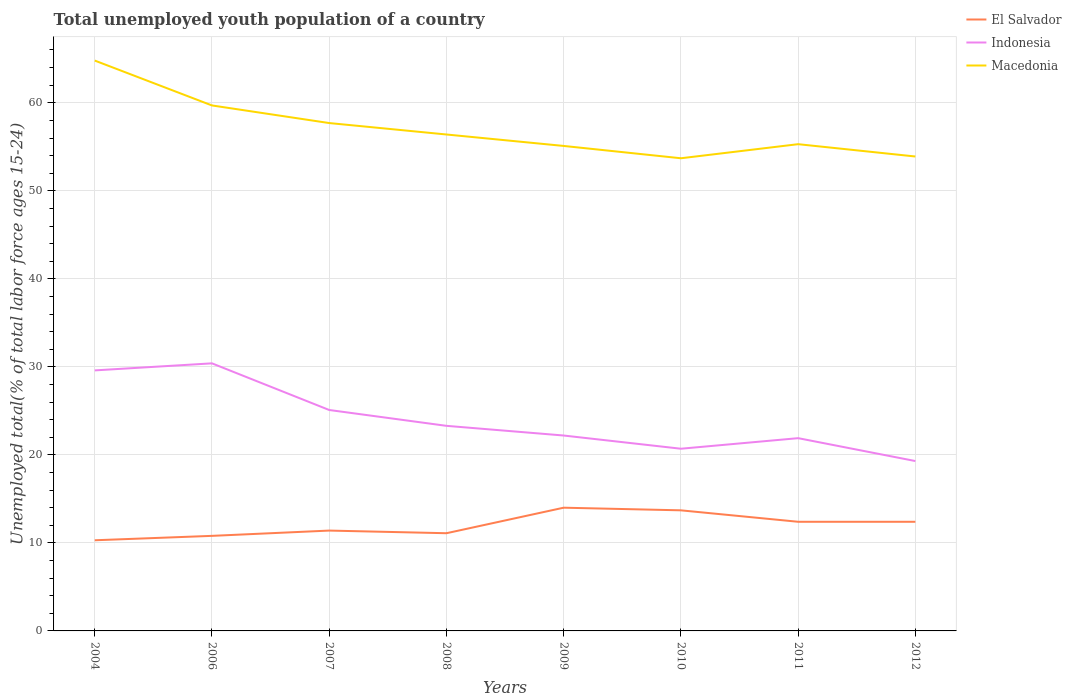How many different coloured lines are there?
Offer a terse response. 3. Is the number of lines equal to the number of legend labels?
Offer a very short reply. Yes. Across all years, what is the maximum percentage of total unemployed youth population of a country in Indonesia?
Offer a very short reply. 19.3. What is the total percentage of total unemployed youth population of a country in Indonesia in the graph?
Keep it short and to the point. 7.7. What is the difference between the highest and the second highest percentage of total unemployed youth population of a country in El Salvador?
Make the answer very short. 3.7. What is the difference between the highest and the lowest percentage of total unemployed youth population of a country in Indonesia?
Your response must be concise. 3. Is the percentage of total unemployed youth population of a country in El Salvador strictly greater than the percentage of total unemployed youth population of a country in Macedonia over the years?
Keep it short and to the point. Yes. How many lines are there?
Ensure brevity in your answer.  3. How many years are there in the graph?
Provide a short and direct response. 8. Are the values on the major ticks of Y-axis written in scientific E-notation?
Make the answer very short. No. Where does the legend appear in the graph?
Your answer should be very brief. Top right. What is the title of the graph?
Make the answer very short. Total unemployed youth population of a country. Does "Curacao" appear as one of the legend labels in the graph?
Ensure brevity in your answer.  No. What is the label or title of the Y-axis?
Provide a succinct answer. Unemployed total(% of total labor force ages 15-24). What is the Unemployed total(% of total labor force ages 15-24) of El Salvador in 2004?
Your answer should be compact. 10.3. What is the Unemployed total(% of total labor force ages 15-24) in Indonesia in 2004?
Provide a short and direct response. 29.6. What is the Unemployed total(% of total labor force ages 15-24) in Macedonia in 2004?
Offer a terse response. 64.8. What is the Unemployed total(% of total labor force ages 15-24) of El Salvador in 2006?
Keep it short and to the point. 10.8. What is the Unemployed total(% of total labor force ages 15-24) in Indonesia in 2006?
Make the answer very short. 30.4. What is the Unemployed total(% of total labor force ages 15-24) of Macedonia in 2006?
Your response must be concise. 59.7. What is the Unemployed total(% of total labor force ages 15-24) in El Salvador in 2007?
Make the answer very short. 11.4. What is the Unemployed total(% of total labor force ages 15-24) of Indonesia in 2007?
Keep it short and to the point. 25.1. What is the Unemployed total(% of total labor force ages 15-24) of Macedonia in 2007?
Ensure brevity in your answer.  57.7. What is the Unemployed total(% of total labor force ages 15-24) of El Salvador in 2008?
Ensure brevity in your answer.  11.1. What is the Unemployed total(% of total labor force ages 15-24) in Indonesia in 2008?
Your answer should be compact. 23.3. What is the Unemployed total(% of total labor force ages 15-24) in Macedonia in 2008?
Give a very brief answer. 56.4. What is the Unemployed total(% of total labor force ages 15-24) in El Salvador in 2009?
Provide a short and direct response. 14. What is the Unemployed total(% of total labor force ages 15-24) in Indonesia in 2009?
Your answer should be compact. 22.2. What is the Unemployed total(% of total labor force ages 15-24) in Macedonia in 2009?
Your answer should be compact. 55.1. What is the Unemployed total(% of total labor force ages 15-24) of El Salvador in 2010?
Your answer should be compact. 13.7. What is the Unemployed total(% of total labor force ages 15-24) in Indonesia in 2010?
Provide a short and direct response. 20.7. What is the Unemployed total(% of total labor force ages 15-24) of Macedonia in 2010?
Provide a short and direct response. 53.7. What is the Unemployed total(% of total labor force ages 15-24) of El Salvador in 2011?
Ensure brevity in your answer.  12.4. What is the Unemployed total(% of total labor force ages 15-24) in Indonesia in 2011?
Keep it short and to the point. 21.9. What is the Unemployed total(% of total labor force ages 15-24) of Macedonia in 2011?
Your response must be concise. 55.3. What is the Unemployed total(% of total labor force ages 15-24) of El Salvador in 2012?
Provide a short and direct response. 12.4. What is the Unemployed total(% of total labor force ages 15-24) of Indonesia in 2012?
Ensure brevity in your answer.  19.3. What is the Unemployed total(% of total labor force ages 15-24) of Macedonia in 2012?
Offer a terse response. 53.9. Across all years, what is the maximum Unemployed total(% of total labor force ages 15-24) of Indonesia?
Give a very brief answer. 30.4. Across all years, what is the maximum Unemployed total(% of total labor force ages 15-24) of Macedonia?
Ensure brevity in your answer.  64.8. Across all years, what is the minimum Unemployed total(% of total labor force ages 15-24) of El Salvador?
Your answer should be compact. 10.3. Across all years, what is the minimum Unemployed total(% of total labor force ages 15-24) in Indonesia?
Make the answer very short. 19.3. Across all years, what is the minimum Unemployed total(% of total labor force ages 15-24) in Macedonia?
Provide a succinct answer. 53.7. What is the total Unemployed total(% of total labor force ages 15-24) in El Salvador in the graph?
Your answer should be very brief. 96.1. What is the total Unemployed total(% of total labor force ages 15-24) in Indonesia in the graph?
Offer a very short reply. 192.5. What is the total Unemployed total(% of total labor force ages 15-24) of Macedonia in the graph?
Your answer should be very brief. 456.6. What is the difference between the Unemployed total(% of total labor force ages 15-24) in El Salvador in 2004 and that in 2006?
Provide a short and direct response. -0.5. What is the difference between the Unemployed total(% of total labor force ages 15-24) in El Salvador in 2004 and that in 2008?
Ensure brevity in your answer.  -0.8. What is the difference between the Unemployed total(% of total labor force ages 15-24) in Indonesia in 2004 and that in 2008?
Offer a very short reply. 6.3. What is the difference between the Unemployed total(% of total labor force ages 15-24) of El Salvador in 2004 and that in 2010?
Offer a very short reply. -3.4. What is the difference between the Unemployed total(% of total labor force ages 15-24) of Indonesia in 2004 and that in 2010?
Give a very brief answer. 8.9. What is the difference between the Unemployed total(% of total labor force ages 15-24) of El Salvador in 2004 and that in 2011?
Provide a succinct answer. -2.1. What is the difference between the Unemployed total(% of total labor force ages 15-24) in El Salvador in 2004 and that in 2012?
Keep it short and to the point. -2.1. What is the difference between the Unemployed total(% of total labor force ages 15-24) in Indonesia in 2006 and that in 2007?
Provide a succinct answer. 5.3. What is the difference between the Unemployed total(% of total labor force ages 15-24) in Macedonia in 2006 and that in 2007?
Make the answer very short. 2. What is the difference between the Unemployed total(% of total labor force ages 15-24) of Indonesia in 2006 and that in 2008?
Your response must be concise. 7.1. What is the difference between the Unemployed total(% of total labor force ages 15-24) in Macedonia in 2006 and that in 2008?
Make the answer very short. 3.3. What is the difference between the Unemployed total(% of total labor force ages 15-24) of El Salvador in 2006 and that in 2009?
Provide a short and direct response. -3.2. What is the difference between the Unemployed total(% of total labor force ages 15-24) in Indonesia in 2006 and that in 2009?
Provide a succinct answer. 8.2. What is the difference between the Unemployed total(% of total labor force ages 15-24) of El Salvador in 2006 and that in 2010?
Give a very brief answer. -2.9. What is the difference between the Unemployed total(% of total labor force ages 15-24) of Indonesia in 2006 and that in 2010?
Offer a very short reply. 9.7. What is the difference between the Unemployed total(% of total labor force ages 15-24) in Macedonia in 2006 and that in 2011?
Give a very brief answer. 4.4. What is the difference between the Unemployed total(% of total labor force ages 15-24) in Indonesia in 2006 and that in 2012?
Ensure brevity in your answer.  11.1. What is the difference between the Unemployed total(% of total labor force ages 15-24) in Macedonia in 2006 and that in 2012?
Ensure brevity in your answer.  5.8. What is the difference between the Unemployed total(% of total labor force ages 15-24) of Indonesia in 2007 and that in 2008?
Keep it short and to the point. 1.8. What is the difference between the Unemployed total(% of total labor force ages 15-24) in Macedonia in 2007 and that in 2008?
Provide a short and direct response. 1.3. What is the difference between the Unemployed total(% of total labor force ages 15-24) in Indonesia in 2007 and that in 2009?
Offer a terse response. 2.9. What is the difference between the Unemployed total(% of total labor force ages 15-24) in Indonesia in 2007 and that in 2010?
Your answer should be very brief. 4.4. What is the difference between the Unemployed total(% of total labor force ages 15-24) in El Salvador in 2007 and that in 2012?
Ensure brevity in your answer.  -1. What is the difference between the Unemployed total(% of total labor force ages 15-24) in Macedonia in 2007 and that in 2012?
Your answer should be compact. 3.8. What is the difference between the Unemployed total(% of total labor force ages 15-24) of Indonesia in 2008 and that in 2009?
Make the answer very short. 1.1. What is the difference between the Unemployed total(% of total labor force ages 15-24) of El Salvador in 2008 and that in 2010?
Give a very brief answer. -2.6. What is the difference between the Unemployed total(% of total labor force ages 15-24) in Macedonia in 2008 and that in 2010?
Give a very brief answer. 2.7. What is the difference between the Unemployed total(% of total labor force ages 15-24) in Indonesia in 2008 and that in 2011?
Your response must be concise. 1.4. What is the difference between the Unemployed total(% of total labor force ages 15-24) of Macedonia in 2008 and that in 2011?
Ensure brevity in your answer.  1.1. What is the difference between the Unemployed total(% of total labor force ages 15-24) of Indonesia in 2008 and that in 2012?
Offer a very short reply. 4. What is the difference between the Unemployed total(% of total labor force ages 15-24) of El Salvador in 2009 and that in 2010?
Provide a short and direct response. 0.3. What is the difference between the Unemployed total(% of total labor force ages 15-24) in Macedonia in 2009 and that in 2010?
Offer a terse response. 1.4. What is the difference between the Unemployed total(% of total labor force ages 15-24) in El Salvador in 2009 and that in 2011?
Offer a very short reply. 1.6. What is the difference between the Unemployed total(% of total labor force ages 15-24) of Macedonia in 2009 and that in 2011?
Offer a terse response. -0.2. What is the difference between the Unemployed total(% of total labor force ages 15-24) of El Salvador in 2009 and that in 2012?
Your answer should be compact. 1.6. What is the difference between the Unemployed total(% of total labor force ages 15-24) of Indonesia in 2009 and that in 2012?
Your response must be concise. 2.9. What is the difference between the Unemployed total(% of total labor force ages 15-24) in Macedonia in 2009 and that in 2012?
Provide a short and direct response. 1.2. What is the difference between the Unemployed total(% of total labor force ages 15-24) of El Salvador in 2010 and that in 2011?
Offer a very short reply. 1.3. What is the difference between the Unemployed total(% of total labor force ages 15-24) of Indonesia in 2010 and that in 2011?
Your answer should be compact. -1.2. What is the difference between the Unemployed total(% of total labor force ages 15-24) in Indonesia in 2010 and that in 2012?
Ensure brevity in your answer.  1.4. What is the difference between the Unemployed total(% of total labor force ages 15-24) in El Salvador in 2011 and that in 2012?
Your answer should be compact. 0. What is the difference between the Unemployed total(% of total labor force ages 15-24) of El Salvador in 2004 and the Unemployed total(% of total labor force ages 15-24) of Indonesia in 2006?
Provide a succinct answer. -20.1. What is the difference between the Unemployed total(% of total labor force ages 15-24) in El Salvador in 2004 and the Unemployed total(% of total labor force ages 15-24) in Macedonia in 2006?
Provide a succinct answer. -49.4. What is the difference between the Unemployed total(% of total labor force ages 15-24) in Indonesia in 2004 and the Unemployed total(% of total labor force ages 15-24) in Macedonia in 2006?
Give a very brief answer. -30.1. What is the difference between the Unemployed total(% of total labor force ages 15-24) of El Salvador in 2004 and the Unemployed total(% of total labor force ages 15-24) of Indonesia in 2007?
Provide a short and direct response. -14.8. What is the difference between the Unemployed total(% of total labor force ages 15-24) in El Salvador in 2004 and the Unemployed total(% of total labor force ages 15-24) in Macedonia in 2007?
Offer a very short reply. -47.4. What is the difference between the Unemployed total(% of total labor force ages 15-24) in Indonesia in 2004 and the Unemployed total(% of total labor force ages 15-24) in Macedonia in 2007?
Offer a terse response. -28.1. What is the difference between the Unemployed total(% of total labor force ages 15-24) of El Salvador in 2004 and the Unemployed total(% of total labor force ages 15-24) of Indonesia in 2008?
Offer a terse response. -13. What is the difference between the Unemployed total(% of total labor force ages 15-24) of El Salvador in 2004 and the Unemployed total(% of total labor force ages 15-24) of Macedonia in 2008?
Your answer should be very brief. -46.1. What is the difference between the Unemployed total(% of total labor force ages 15-24) in Indonesia in 2004 and the Unemployed total(% of total labor force ages 15-24) in Macedonia in 2008?
Provide a short and direct response. -26.8. What is the difference between the Unemployed total(% of total labor force ages 15-24) in El Salvador in 2004 and the Unemployed total(% of total labor force ages 15-24) in Indonesia in 2009?
Provide a succinct answer. -11.9. What is the difference between the Unemployed total(% of total labor force ages 15-24) of El Salvador in 2004 and the Unemployed total(% of total labor force ages 15-24) of Macedonia in 2009?
Make the answer very short. -44.8. What is the difference between the Unemployed total(% of total labor force ages 15-24) of Indonesia in 2004 and the Unemployed total(% of total labor force ages 15-24) of Macedonia in 2009?
Ensure brevity in your answer.  -25.5. What is the difference between the Unemployed total(% of total labor force ages 15-24) of El Salvador in 2004 and the Unemployed total(% of total labor force ages 15-24) of Indonesia in 2010?
Give a very brief answer. -10.4. What is the difference between the Unemployed total(% of total labor force ages 15-24) of El Salvador in 2004 and the Unemployed total(% of total labor force ages 15-24) of Macedonia in 2010?
Your answer should be very brief. -43.4. What is the difference between the Unemployed total(% of total labor force ages 15-24) in Indonesia in 2004 and the Unemployed total(% of total labor force ages 15-24) in Macedonia in 2010?
Your response must be concise. -24.1. What is the difference between the Unemployed total(% of total labor force ages 15-24) of El Salvador in 2004 and the Unemployed total(% of total labor force ages 15-24) of Macedonia in 2011?
Offer a terse response. -45. What is the difference between the Unemployed total(% of total labor force ages 15-24) of Indonesia in 2004 and the Unemployed total(% of total labor force ages 15-24) of Macedonia in 2011?
Ensure brevity in your answer.  -25.7. What is the difference between the Unemployed total(% of total labor force ages 15-24) of El Salvador in 2004 and the Unemployed total(% of total labor force ages 15-24) of Indonesia in 2012?
Make the answer very short. -9. What is the difference between the Unemployed total(% of total labor force ages 15-24) of El Salvador in 2004 and the Unemployed total(% of total labor force ages 15-24) of Macedonia in 2012?
Give a very brief answer. -43.6. What is the difference between the Unemployed total(% of total labor force ages 15-24) in Indonesia in 2004 and the Unemployed total(% of total labor force ages 15-24) in Macedonia in 2012?
Make the answer very short. -24.3. What is the difference between the Unemployed total(% of total labor force ages 15-24) in El Salvador in 2006 and the Unemployed total(% of total labor force ages 15-24) in Indonesia in 2007?
Your answer should be very brief. -14.3. What is the difference between the Unemployed total(% of total labor force ages 15-24) of El Salvador in 2006 and the Unemployed total(% of total labor force ages 15-24) of Macedonia in 2007?
Offer a very short reply. -46.9. What is the difference between the Unemployed total(% of total labor force ages 15-24) of Indonesia in 2006 and the Unemployed total(% of total labor force ages 15-24) of Macedonia in 2007?
Keep it short and to the point. -27.3. What is the difference between the Unemployed total(% of total labor force ages 15-24) of El Salvador in 2006 and the Unemployed total(% of total labor force ages 15-24) of Macedonia in 2008?
Keep it short and to the point. -45.6. What is the difference between the Unemployed total(% of total labor force ages 15-24) of El Salvador in 2006 and the Unemployed total(% of total labor force ages 15-24) of Macedonia in 2009?
Your answer should be compact. -44.3. What is the difference between the Unemployed total(% of total labor force ages 15-24) in Indonesia in 2006 and the Unemployed total(% of total labor force ages 15-24) in Macedonia in 2009?
Give a very brief answer. -24.7. What is the difference between the Unemployed total(% of total labor force ages 15-24) of El Salvador in 2006 and the Unemployed total(% of total labor force ages 15-24) of Indonesia in 2010?
Make the answer very short. -9.9. What is the difference between the Unemployed total(% of total labor force ages 15-24) in El Salvador in 2006 and the Unemployed total(% of total labor force ages 15-24) in Macedonia in 2010?
Give a very brief answer. -42.9. What is the difference between the Unemployed total(% of total labor force ages 15-24) of Indonesia in 2006 and the Unemployed total(% of total labor force ages 15-24) of Macedonia in 2010?
Provide a succinct answer. -23.3. What is the difference between the Unemployed total(% of total labor force ages 15-24) of El Salvador in 2006 and the Unemployed total(% of total labor force ages 15-24) of Macedonia in 2011?
Provide a succinct answer. -44.5. What is the difference between the Unemployed total(% of total labor force ages 15-24) of Indonesia in 2006 and the Unemployed total(% of total labor force ages 15-24) of Macedonia in 2011?
Provide a succinct answer. -24.9. What is the difference between the Unemployed total(% of total labor force ages 15-24) of El Salvador in 2006 and the Unemployed total(% of total labor force ages 15-24) of Macedonia in 2012?
Offer a terse response. -43.1. What is the difference between the Unemployed total(% of total labor force ages 15-24) of Indonesia in 2006 and the Unemployed total(% of total labor force ages 15-24) of Macedonia in 2012?
Provide a short and direct response. -23.5. What is the difference between the Unemployed total(% of total labor force ages 15-24) of El Salvador in 2007 and the Unemployed total(% of total labor force ages 15-24) of Indonesia in 2008?
Your answer should be compact. -11.9. What is the difference between the Unemployed total(% of total labor force ages 15-24) in El Salvador in 2007 and the Unemployed total(% of total labor force ages 15-24) in Macedonia in 2008?
Give a very brief answer. -45. What is the difference between the Unemployed total(% of total labor force ages 15-24) of Indonesia in 2007 and the Unemployed total(% of total labor force ages 15-24) of Macedonia in 2008?
Provide a succinct answer. -31.3. What is the difference between the Unemployed total(% of total labor force ages 15-24) in El Salvador in 2007 and the Unemployed total(% of total labor force ages 15-24) in Macedonia in 2009?
Your answer should be very brief. -43.7. What is the difference between the Unemployed total(% of total labor force ages 15-24) in El Salvador in 2007 and the Unemployed total(% of total labor force ages 15-24) in Indonesia in 2010?
Your response must be concise. -9.3. What is the difference between the Unemployed total(% of total labor force ages 15-24) of El Salvador in 2007 and the Unemployed total(% of total labor force ages 15-24) of Macedonia in 2010?
Provide a short and direct response. -42.3. What is the difference between the Unemployed total(% of total labor force ages 15-24) of Indonesia in 2007 and the Unemployed total(% of total labor force ages 15-24) of Macedonia in 2010?
Keep it short and to the point. -28.6. What is the difference between the Unemployed total(% of total labor force ages 15-24) of El Salvador in 2007 and the Unemployed total(% of total labor force ages 15-24) of Macedonia in 2011?
Your answer should be very brief. -43.9. What is the difference between the Unemployed total(% of total labor force ages 15-24) of Indonesia in 2007 and the Unemployed total(% of total labor force ages 15-24) of Macedonia in 2011?
Provide a short and direct response. -30.2. What is the difference between the Unemployed total(% of total labor force ages 15-24) in El Salvador in 2007 and the Unemployed total(% of total labor force ages 15-24) in Indonesia in 2012?
Ensure brevity in your answer.  -7.9. What is the difference between the Unemployed total(% of total labor force ages 15-24) in El Salvador in 2007 and the Unemployed total(% of total labor force ages 15-24) in Macedonia in 2012?
Keep it short and to the point. -42.5. What is the difference between the Unemployed total(% of total labor force ages 15-24) in Indonesia in 2007 and the Unemployed total(% of total labor force ages 15-24) in Macedonia in 2012?
Provide a succinct answer. -28.8. What is the difference between the Unemployed total(% of total labor force ages 15-24) in El Salvador in 2008 and the Unemployed total(% of total labor force ages 15-24) in Macedonia in 2009?
Provide a short and direct response. -44. What is the difference between the Unemployed total(% of total labor force ages 15-24) of Indonesia in 2008 and the Unemployed total(% of total labor force ages 15-24) of Macedonia in 2009?
Keep it short and to the point. -31.8. What is the difference between the Unemployed total(% of total labor force ages 15-24) of El Salvador in 2008 and the Unemployed total(% of total labor force ages 15-24) of Macedonia in 2010?
Offer a very short reply. -42.6. What is the difference between the Unemployed total(% of total labor force ages 15-24) of Indonesia in 2008 and the Unemployed total(% of total labor force ages 15-24) of Macedonia in 2010?
Keep it short and to the point. -30.4. What is the difference between the Unemployed total(% of total labor force ages 15-24) in El Salvador in 2008 and the Unemployed total(% of total labor force ages 15-24) in Indonesia in 2011?
Provide a succinct answer. -10.8. What is the difference between the Unemployed total(% of total labor force ages 15-24) in El Salvador in 2008 and the Unemployed total(% of total labor force ages 15-24) in Macedonia in 2011?
Ensure brevity in your answer.  -44.2. What is the difference between the Unemployed total(% of total labor force ages 15-24) of Indonesia in 2008 and the Unemployed total(% of total labor force ages 15-24) of Macedonia in 2011?
Provide a succinct answer. -32. What is the difference between the Unemployed total(% of total labor force ages 15-24) in El Salvador in 2008 and the Unemployed total(% of total labor force ages 15-24) in Indonesia in 2012?
Your answer should be compact. -8.2. What is the difference between the Unemployed total(% of total labor force ages 15-24) in El Salvador in 2008 and the Unemployed total(% of total labor force ages 15-24) in Macedonia in 2012?
Give a very brief answer. -42.8. What is the difference between the Unemployed total(% of total labor force ages 15-24) of Indonesia in 2008 and the Unemployed total(% of total labor force ages 15-24) of Macedonia in 2012?
Offer a very short reply. -30.6. What is the difference between the Unemployed total(% of total labor force ages 15-24) in El Salvador in 2009 and the Unemployed total(% of total labor force ages 15-24) in Macedonia in 2010?
Give a very brief answer. -39.7. What is the difference between the Unemployed total(% of total labor force ages 15-24) in Indonesia in 2009 and the Unemployed total(% of total labor force ages 15-24) in Macedonia in 2010?
Give a very brief answer. -31.5. What is the difference between the Unemployed total(% of total labor force ages 15-24) in El Salvador in 2009 and the Unemployed total(% of total labor force ages 15-24) in Indonesia in 2011?
Keep it short and to the point. -7.9. What is the difference between the Unemployed total(% of total labor force ages 15-24) of El Salvador in 2009 and the Unemployed total(% of total labor force ages 15-24) of Macedonia in 2011?
Keep it short and to the point. -41.3. What is the difference between the Unemployed total(% of total labor force ages 15-24) in Indonesia in 2009 and the Unemployed total(% of total labor force ages 15-24) in Macedonia in 2011?
Provide a succinct answer. -33.1. What is the difference between the Unemployed total(% of total labor force ages 15-24) in El Salvador in 2009 and the Unemployed total(% of total labor force ages 15-24) in Indonesia in 2012?
Provide a succinct answer. -5.3. What is the difference between the Unemployed total(% of total labor force ages 15-24) of El Salvador in 2009 and the Unemployed total(% of total labor force ages 15-24) of Macedonia in 2012?
Your response must be concise. -39.9. What is the difference between the Unemployed total(% of total labor force ages 15-24) in Indonesia in 2009 and the Unemployed total(% of total labor force ages 15-24) in Macedonia in 2012?
Ensure brevity in your answer.  -31.7. What is the difference between the Unemployed total(% of total labor force ages 15-24) in El Salvador in 2010 and the Unemployed total(% of total labor force ages 15-24) in Indonesia in 2011?
Give a very brief answer. -8.2. What is the difference between the Unemployed total(% of total labor force ages 15-24) in El Salvador in 2010 and the Unemployed total(% of total labor force ages 15-24) in Macedonia in 2011?
Make the answer very short. -41.6. What is the difference between the Unemployed total(% of total labor force ages 15-24) in Indonesia in 2010 and the Unemployed total(% of total labor force ages 15-24) in Macedonia in 2011?
Your answer should be compact. -34.6. What is the difference between the Unemployed total(% of total labor force ages 15-24) in El Salvador in 2010 and the Unemployed total(% of total labor force ages 15-24) in Macedonia in 2012?
Offer a very short reply. -40.2. What is the difference between the Unemployed total(% of total labor force ages 15-24) of Indonesia in 2010 and the Unemployed total(% of total labor force ages 15-24) of Macedonia in 2012?
Provide a short and direct response. -33.2. What is the difference between the Unemployed total(% of total labor force ages 15-24) in El Salvador in 2011 and the Unemployed total(% of total labor force ages 15-24) in Macedonia in 2012?
Provide a short and direct response. -41.5. What is the difference between the Unemployed total(% of total labor force ages 15-24) in Indonesia in 2011 and the Unemployed total(% of total labor force ages 15-24) in Macedonia in 2012?
Offer a very short reply. -32. What is the average Unemployed total(% of total labor force ages 15-24) of El Salvador per year?
Your answer should be compact. 12.01. What is the average Unemployed total(% of total labor force ages 15-24) of Indonesia per year?
Offer a very short reply. 24.06. What is the average Unemployed total(% of total labor force ages 15-24) of Macedonia per year?
Offer a very short reply. 57.08. In the year 2004, what is the difference between the Unemployed total(% of total labor force ages 15-24) of El Salvador and Unemployed total(% of total labor force ages 15-24) of Indonesia?
Keep it short and to the point. -19.3. In the year 2004, what is the difference between the Unemployed total(% of total labor force ages 15-24) in El Salvador and Unemployed total(% of total labor force ages 15-24) in Macedonia?
Your answer should be compact. -54.5. In the year 2004, what is the difference between the Unemployed total(% of total labor force ages 15-24) of Indonesia and Unemployed total(% of total labor force ages 15-24) of Macedonia?
Provide a succinct answer. -35.2. In the year 2006, what is the difference between the Unemployed total(% of total labor force ages 15-24) in El Salvador and Unemployed total(% of total labor force ages 15-24) in Indonesia?
Offer a terse response. -19.6. In the year 2006, what is the difference between the Unemployed total(% of total labor force ages 15-24) in El Salvador and Unemployed total(% of total labor force ages 15-24) in Macedonia?
Your answer should be compact. -48.9. In the year 2006, what is the difference between the Unemployed total(% of total labor force ages 15-24) in Indonesia and Unemployed total(% of total labor force ages 15-24) in Macedonia?
Ensure brevity in your answer.  -29.3. In the year 2007, what is the difference between the Unemployed total(% of total labor force ages 15-24) in El Salvador and Unemployed total(% of total labor force ages 15-24) in Indonesia?
Your answer should be compact. -13.7. In the year 2007, what is the difference between the Unemployed total(% of total labor force ages 15-24) of El Salvador and Unemployed total(% of total labor force ages 15-24) of Macedonia?
Keep it short and to the point. -46.3. In the year 2007, what is the difference between the Unemployed total(% of total labor force ages 15-24) of Indonesia and Unemployed total(% of total labor force ages 15-24) of Macedonia?
Ensure brevity in your answer.  -32.6. In the year 2008, what is the difference between the Unemployed total(% of total labor force ages 15-24) of El Salvador and Unemployed total(% of total labor force ages 15-24) of Indonesia?
Give a very brief answer. -12.2. In the year 2008, what is the difference between the Unemployed total(% of total labor force ages 15-24) in El Salvador and Unemployed total(% of total labor force ages 15-24) in Macedonia?
Provide a succinct answer. -45.3. In the year 2008, what is the difference between the Unemployed total(% of total labor force ages 15-24) in Indonesia and Unemployed total(% of total labor force ages 15-24) in Macedonia?
Your response must be concise. -33.1. In the year 2009, what is the difference between the Unemployed total(% of total labor force ages 15-24) of El Salvador and Unemployed total(% of total labor force ages 15-24) of Indonesia?
Give a very brief answer. -8.2. In the year 2009, what is the difference between the Unemployed total(% of total labor force ages 15-24) of El Salvador and Unemployed total(% of total labor force ages 15-24) of Macedonia?
Give a very brief answer. -41.1. In the year 2009, what is the difference between the Unemployed total(% of total labor force ages 15-24) in Indonesia and Unemployed total(% of total labor force ages 15-24) in Macedonia?
Give a very brief answer. -32.9. In the year 2010, what is the difference between the Unemployed total(% of total labor force ages 15-24) in El Salvador and Unemployed total(% of total labor force ages 15-24) in Indonesia?
Make the answer very short. -7. In the year 2010, what is the difference between the Unemployed total(% of total labor force ages 15-24) of El Salvador and Unemployed total(% of total labor force ages 15-24) of Macedonia?
Make the answer very short. -40. In the year 2010, what is the difference between the Unemployed total(% of total labor force ages 15-24) of Indonesia and Unemployed total(% of total labor force ages 15-24) of Macedonia?
Keep it short and to the point. -33. In the year 2011, what is the difference between the Unemployed total(% of total labor force ages 15-24) of El Salvador and Unemployed total(% of total labor force ages 15-24) of Indonesia?
Keep it short and to the point. -9.5. In the year 2011, what is the difference between the Unemployed total(% of total labor force ages 15-24) in El Salvador and Unemployed total(% of total labor force ages 15-24) in Macedonia?
Give a very brief answer. -42.9. In the year 2011, what is the difference between the Unemployed total(% of total labor force ages 15-24) of Indonesia and Unemployed total(% of total labor force ages 15-24) of Macedonia?
Give a very brief answer. -33.4. In the year 2012, what is the difference between the Unemployed total(% of total labor force ages 15-24) in El Salvador and Unemployed total(% of total labor force ages 15-24) in Indonesia?
Your answer should be very brief. -6.9. In the year 2012, what is the difference between the Unemployed total(% of total labor force ages 15-24) in El Salvador and Unemployed total(% of total labor force ages 15-24) in Macedonia?
Give a very brief answer. -41.5. In the year 2012, what is the difference between the Unemployed total(% of total labor force ages 15-24) of Indonesia and Unemployed total(% of total labor force ages 15-24) of Macedonia?
Your response must be concise. -34.6. What is the ratio of the Unemployed total(% of total labor force ages 15-24) of El Salvador in 2004 to that in 2006?
Keep it short and to the point. 0.95. What is the ratio of the Unemployed total(% of total labor force ages 15-24) in Indonesia in 2004 to that in 2006?
Give a very brief answer. 0.97. What is the ratio of the Unemployed total(% of total labor force ages 15-24) of Macedonia in 2004 to that in 2006?
Your response must be concise. 1.09. What is the ratio of the Unemployed total(% of total labor force ages 15-24) in El Salvador in 2004 to that in 2007?
Offer a very short reply. 0.9. What is the ratio of the Unemployed total(% of total labor force ages 15-24) in Indonesia in 2004 to that in 2007?
Your answer should be compact. 1.18. What is the ratio of the Unemployed total(% of total labor force ages 15-24) of Macedonia in 2004 to that in 2007?
Ensure brevity in your answer.  1.12. What is the ratio of the Unemployed total(% of total labor force ages 15-24) of El Salvador in 2004 to that in 2008?
Your answer should be very brief. 0.93. What is the ratio of the Unemployed total(% of total labor force ages 15-24) in Indonesia in 2004 to that in 2008?
Make the answer very short. 1.27. What is the ratio of the Unemployed total(% of total labor force ages 15-24) in Macedonia in 2004 to that in 2008?
Offer a very short reply. 1.15. What is the ratio of the Unemployed total(% of total labor force ages 15-24) of El Salvador in 2004 to that in 2009?
Ensure brevity in your answer.  0.74. What is the ratio of the Unemployed total(% of total labor force ages 15-24) of Macedonia in 2004 to that in 2009?
Your answer should be compact. 1.18. What is the ratio of the Unemployed total(% of total labor force ages 15-24) of El Salvador in 2004 to that in 2010?
Make the answer very short. 0.75. What is the ratio of the Unemployed total(% of total labor force ages 15-24) in Indonesia in 2004 to that in 2010?
Provide a succinct answer. 1.43. What is the ratio of the Unemployed total(% of total labor force ages 15-24) in Macedonia in 2004 to that in 2010?
Your answer should be compact. 1.21. What is the ratio of the Unemployed total(% of total labor force ages 15-24) in El Salvador in 2004 to that in 2011?
Give a very brief answer. 0.83. What is the ratio of the Unemployed total(% of total labor force ages 15-24) of Indonesia in 2004 to that in 2011?
Provide a succinct answer. 1.35. What is the ratio of the Unemployed total(% of total labor force ages 15-24) of Macedonia in 2004 to that in 2011?
Your answer should be compact. 1.17. What is the ratio of the Unemployed total(% of total labor force ages 15-24) in El Salvador in 2004 to that in 2012?
Ensure brevity in your answer.  0.83. What is the ratio of the Unemployed total(% of total labor force ages 15-24) in Indonesia in 2004 to that in 2012?
Keep it short and to the point. 1.53. What is the ratio of the Unemployed total(% of total labor force ages 15-24) in Macedonia in 2004 to that in 2012?
Give a very brief answer. 1.2. What is the ratio of the Unemployed total(% of total labor force ages 15-24) of El Salvador in 2006 to that in 2007?
Keep it short and to the point. 0.95. What is the ratio of the Unemployed total(% of total labor force ages 15-24) in Indonesia in 2006 to that in 2007?
Give a very brief answer. 1.21. What is the ratio of the Unemployed total(% of total labor force ages 15-24) in Macedonia in 2006 to that in 2007?
Your answer should be compact. 1.03. What is the ratio of the Unemployed total(% of total labor force ages 15-24) of Indonesia in 2006 to that in 2008?
Give a very brief answer. 1.3. What is the ratio of the Unemployed total(% of total labor force ages 15-24) of Macedonia in 2006 to that in 2008?
Your response must be concise. 1.06. What is the ratio of the Unemployed total(% of total labor force ages 15-24) of El Salvador in 2006 to that in 2009?
Ensure brevity in your answer.  0.77. What is the ratio of the Unemployed total(% of total labor force ages 15-24) in Indonesia in 2006 to that in 2009?
Your answer should be compact. 1.37. What is the ratio of the Unemployed total(% of total labor force ages 15-24) in Macedonia in 2006 to that in 2009?
Your answer should be compact. 1.08. What is the ratio of the Unemployed total(% of total labor force ages 15-24) of El Salvador in 2006 to that in 2010?
Offer a very short reply. 0.79. What is the ratio of the Unemployed total(% of total labor force ages 15-24) of Indonesia in 2006 to that in 2010?
Provide a short and direct response. 1.47. What is the ratio of the Unemployed total(% of total labor force ages 15-24) in Macedonia in 2006 to that in 2010?
Provide a succinct answer. 1.11. What is the ratio of the Unemployed total(% of total labor force ages 15-24) of El Salvador in 2006 to that in 2011?
Ensure brevity in your answer.  0.87. What is the ratio of the Unemployed total(% of total labor force ages 15-24) of Indonesia in 2006 to that in 2011?
Your answer should be compact. 1.39. What is the ratio of the Unemployed total(% of total labor force ages 15-24) of Macedonia in 2006 to that in 2011?
Your answer should be compact. 1.08. What is the ratio of the Unemployed total(% of total labor force ages 15-24) of El Salvador in 2006 to that in 2012?
Offer a very short reply. 0.87. What is the ratio of the Unemployed total(% of total labor force ages 15-24) of Indonesia in 2006 to that in 2012?
Offer a terse response. 1.58. What is the ratio of the Unemployed total(% of total labor force ages 15-24) in Macedonia in 2006 to that in 2012?
Keep it short and to the point. 1.11. What is the ratio of the Unemployed total(% of total labor force ages 15-24) of Indonesia in 2007 to that in 2008?
Keep it short and to the point. 1.08. What is the ratio of the Unemployed total(% of total labor force ages 15-24) of Macedonia in 2007 to that in 2008?
Your answer should be compact. 1.02. What is the ratio of the Unemployed total(% of total labor force ages 15-24) of El Salvador in 2007 to that in 2009?
Keep it short and to the point. 0.81. What is the ratio of the Unemployed total(% of total labor force ages 15-24) in Indonesia in 2007 to that in 2009?
Provide a short and direct response. 1.13. What is the ratio of the Unemployed total(% of total labor force ages 15-24) in Macedonia in 2007 to that in 2009?
Provide a succinct answer. 1.05. What is the ratio of the Unemployed total(% of total labor force ages 15-24) of El Salvador in 2007 to that in 2010?
Offer a terse response. 0.83. What is the ratio of the Unemployed total(% of total labor force ages 15-24) in Indonesia in 2007 to that in 2010?
Your response must be concise. 1.21. What is the ratio of the Unemployed total(% of total labor force ages 15-24) of Macedonia in 2007 to that in 2010?
Your answer should be compact. 1.07. What is the ratio of the Unemployed total(% of total labor force ages 15-24) in El Salvador in 2007 to that in 2011?
Make the answer very short. 0.92. What is the ratio of the Unemployed total(% of total labor force ages 15-24) in Indonesia in 2007 to that in 2011?
Your response must be concise. 1.15. What is the ratio of the Unemployed total(% of total labor force ages 15-24) of Macedonia in 2007 to that in 2011?
Your answer should be compact. 1.04. What is the ratio of the Unemployed total(% of total labor force ages 15-24) in El Salvador in 2007 to that in 2012?
Offer a very short reply. 0.92. What is the ratio of the Unemployed total(% of total labor force ages 15-24) in Indonesia in 2007 to that in 2012?
Your answer should be compact. 1.3. What is the ratio of the Unemployed total(% of total labor force ages 15-24) in Macedonia in 2007 to that in 2012?
Offer a terse response. 1.07. What is the ratio of the Unemployed total(% of total labor force ages 15-24) of El Salvador in 2008 to that in 2009?
Your response must be concise. 0.79. What is the ratio of the Unemployed total(% of total labor force ages 15-24) in Indonesia in 2008 to that in 2009?
Offer a terse response. 1.05. What is the ratio of the Unemployed total(% of total labor force ages 15-24) of Macedonia in 2008 to that in 2009?
Your response must be concise. 1.02. What is the ratio of the Unemployed total(% of total labor force ages 15-24) in El Salvador in 2008 to that in 2010?
Ensure brevity in your answer.  0.81. What is the ratio of the Unemployed total(% of total labor force ages 15-24) of Indonesia in 2008 to that in 2010?
Keep it short and to the point. 1.13. What is the ratio of the Unemployed total(% of total labor force ages 15-24) in Macedonia in 2008 to that in 2010?
Provide a short and direct response. 1.05. What is the ratio of the Unemployed total(% of total labor force ages 15-24) in El Salvador in 2008 to that in 2011?
Your answer should be very brief. 0.9. What is the ratio of the Unemployed total(% of total labor force ages 15-24) in Indonesia in 2008 to that in 2011?
Give a very brief answer. 1.06. What is the ratio of the Unemployed total(% of total labor force ages 15-24) in Macedonia in 2008 to that in 2011?
Offer a terse response. 1.02. What is the ratio of the Unemployed total(% of total labor force ages 15-24) in El Salvador in 2008 to that in 2012?
Your response must be concise. 0.9. What is the ratio of the Unemployed total(% of total labor force ages 15-24) in Indonesia in 2008 to that in 2012?
Provide a short and direct response. 1.21. What is the ratio of the Unemployed total(% of total labor force ages 15-24) of Macedonia in 2008 to that in 2012?
Your answer should be compact. 1.05. What is the ratio of the Unemployed total(% of total labor force ages 15-24) of El Salvador in 2009 to that in 2010?
Provide a succinct answer. 1.02. What is the ratio of the Unemployed total(% of total labor force ages 15-24) in Indonesia in 2009 to that in 2010?
Your response must be concise. 1.07. What is the ratio of the Unemployed total(% of total labor force ages 15-24) of Macedonia in 2009 to that in 2010?
Provide a short and direct response. 1.03. What is the ratio of the Unemployed total(% of total labor force ages 15-24) of El Salvador in 2009 to that in 2011?
Make the answer very short. 1.13. What is the ratio of the Unemployed total(% of total labor force ages 15-24) of Indonesia in 2009 to that in 2011?
Offer a terse response. 1.01. What is the ratio of the Unemployed total(% of total labor force ages 15-24) of Macedonia in 2009 to that in 2011?
Your response must be concise. 1. What is the ratio of the Unemployed total(% of total labor force ages 15-24) in El Salvador in 2009 to that in 2012?
Provide a short and direct response. 1.13. What is the ratio of the Unemployed total(% of total labor force ages 15-24) in Indonesia in 2009 to that in 2012?
Make the answer very short. 1.15. What is the ratio of the Unemployed total(% of total labor force ages 15-24) in Macedonia in 2009 to that in 2012?
Your answer should be very brief. 1.02. What is the ratio of the Unemployed total(% of total labor force ages 15-24) of El Salvador in 2010 to that in 2011?
Give a very brief answer. 1.1. What is the ratio of the Unemployed total(% of total labor force ages 15-24) in Indonesia in 2010 to that in 2011?
Offer a very short reply. 0.95. What is the ratio of the Unemployed total(% of total labor force ages 15-24) of Macedonia in 2010 to that in 2011?
Ensure brevity in your answer.  0.97. What is the ratio of the Unemployed total(% of total labor force ages 15-24) of El Salvador in 2010 to that in 2012?
Keep it short and to the point. 1.1. What is the ratio of the Unemployed total(% of total labor force ages 15-24) in Indonesia in 2010 to that in 2012?
Make the answer very short. 1.07. What is the ratio of the Unemployed total(% of total labor force ages 15-24) in El Salvador in 2011 to that in 2012?
Provide a succinct answer. 1. What is the ratio of the Unemployed total(% of total labor force ages 15-24) in Indonesia in 2011 to that in 2012?
Your answer should be very brief. 1.13. What is the ratio of the Unemployed total(% of total labor force ages 15-24) of Macedonia in 2011 to that in 2012?
Your answer should be very brief. 1.03. What is the difference between the highest and the second highest Unemployed total(% of total labor force ages 15-24) in Indonesia?
Keep it short and to the point. 0.8. What is the difference between the highest and the second highest Unemployed total(% of total labor force ages 15-24) in Macedonia?
Your answer should be compact. 5.1. What is the difference between the highest and the lowest Unemployed total(% of total labor force ages 15-24) in Indonesia?
Give a very brief answer. 11.1. What is the difference between the highest and the lowest Unemployed total(% of total labor force ages 15-24) in Macedonia?
Provide a succinct answer. 11.1. 